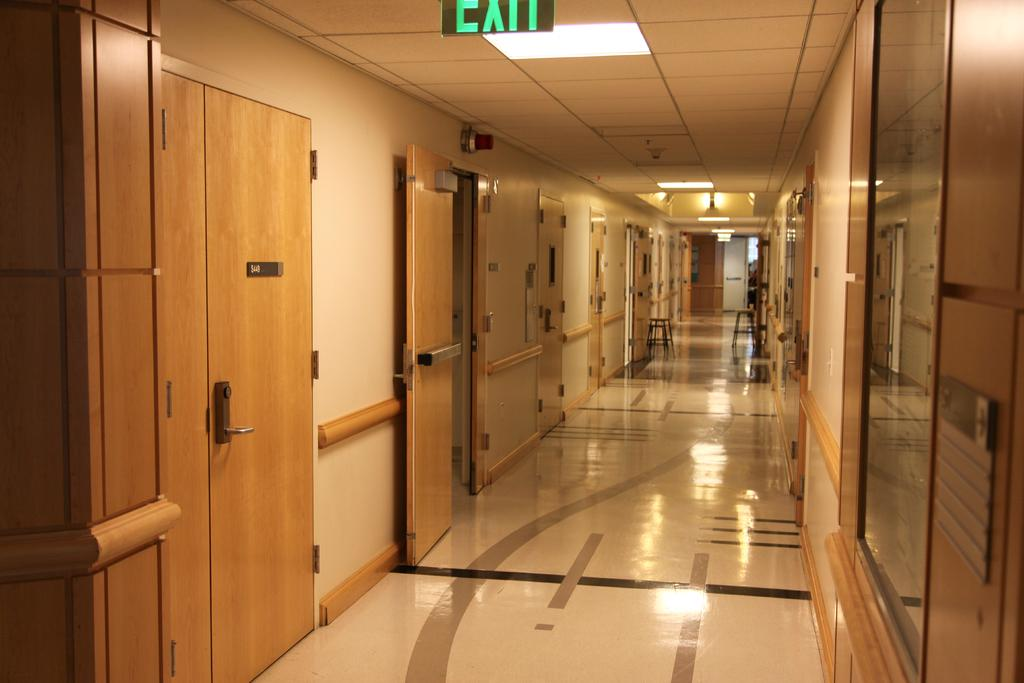What type of space is depicted in the image? There is a corridor in the image. What type of lighting is present in the corridor? There are electric lights in the image. Is there any signage in the corridor? Yes, there is a sign board in the image. What type of emergency indicator is present in the corridor? There is an alarm light in the image. How much wealth is stored in the bookshelves in the image? There are no bookshelves or any indication of wealth present in the image. 